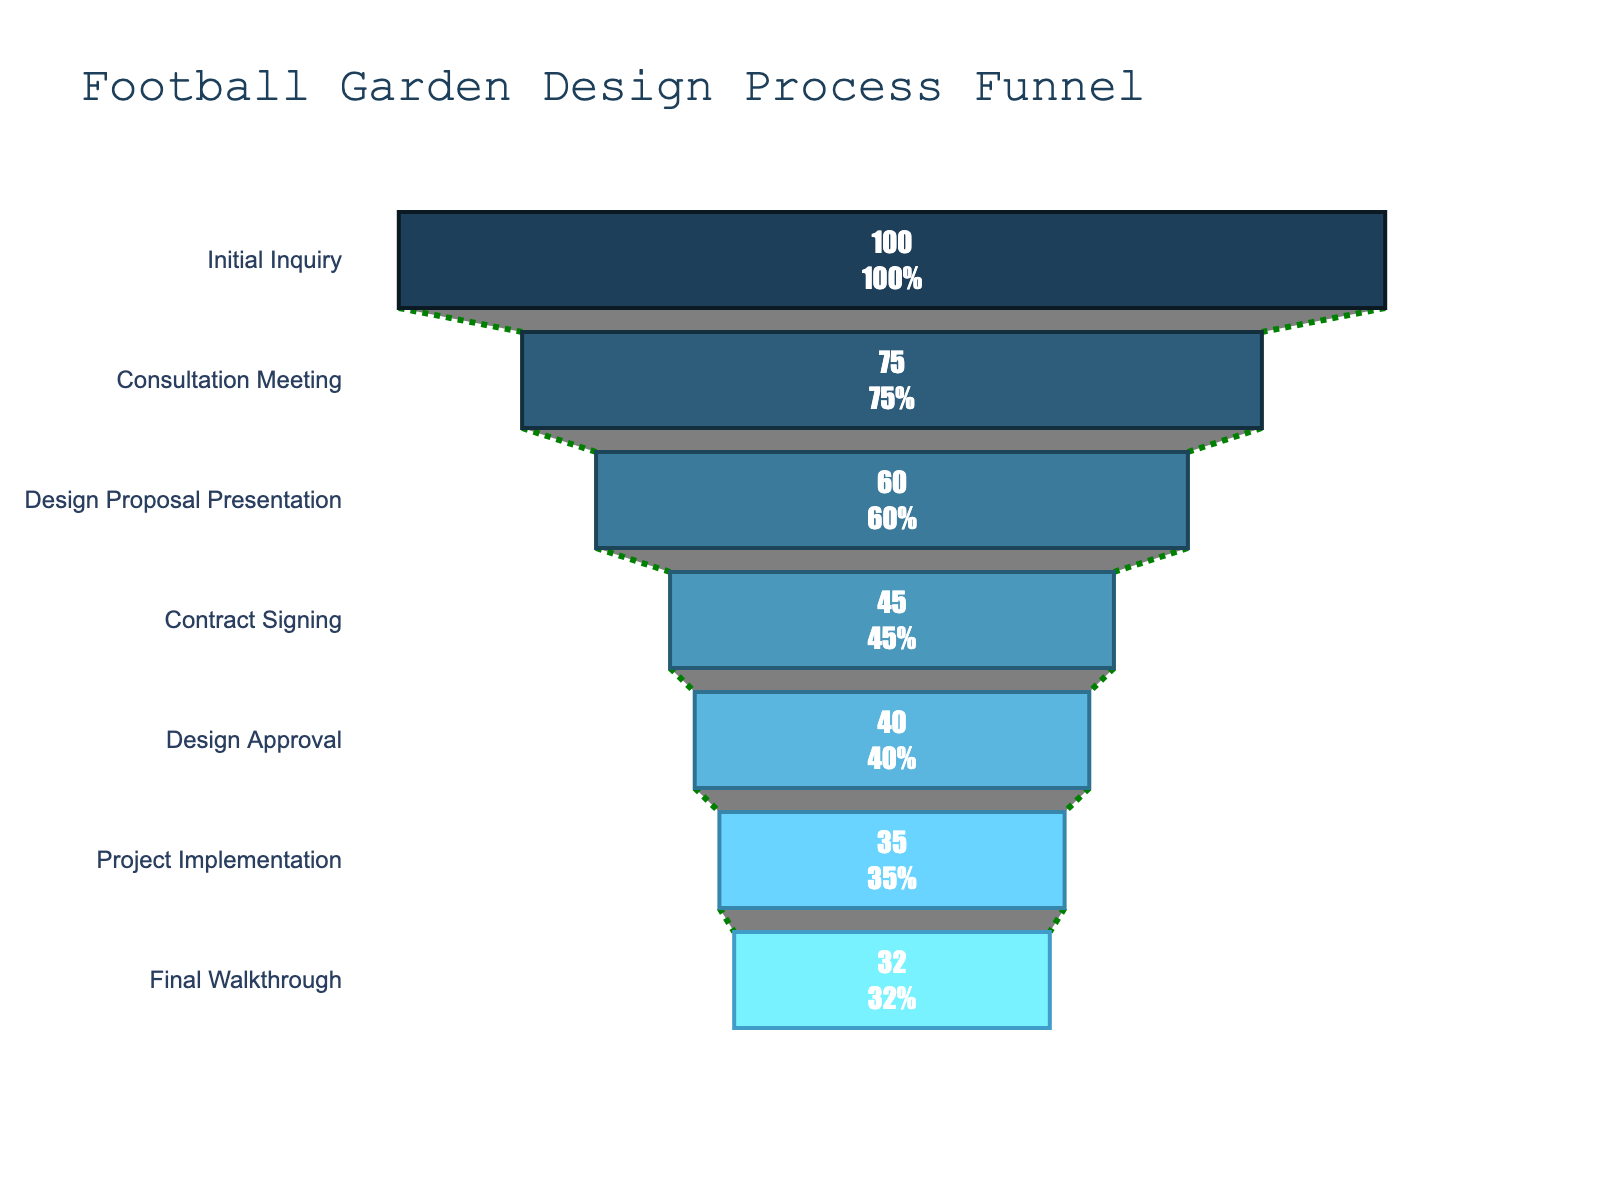What is the title of the funnel chart? The title is usually located at the top of the chart and is labeled as "Football Garden Design Process Funnel". This title indicates the context of the chart, which is relevant to the landscape design process involving football elements.
Answer: Football Garden Design Process Funnel How many stages are shown in the funnel chart? Count the number of distinct stages listed along the Y-axis of the funnel chart. These stages correspond to the different steps in the design process.
Answer: 7 Which stage shows the largest drop in percentage? By examining the percentages between successive stages, the largest drop is identified as the one with the biggest difference. The drop from Initial Inquiry (100) to Consultation Meeting (75) is 25, which is the largest decrement.
Answer: Initial Inquiry to Consultation Meeting What percentage of potential clients sign the contract after the Design Proposal Presentation? Identify the percentage value at the "Contract Signing" stage, which follows the "Design Proposal Presentation" in the funnel chart.
Answer: 45% Out of the stages "Contract Signing" and "Design Approval", which has a lower conversion rate? Compare the percentages of these two stages. The "Contract Signing" stage has 45%, while "Design Approval" has 40%. Therefore, "Design Approval" is lower.
Answer: Design Approval What is the percentage difference between the "Design Proposal Presentation" and the "Final Walkthrough"? Subtract the percentage of the "Final Walkthrough" (32) from "Design Proposal Presentation" (60).
Answer: 28 If 100 people made an Initial Inquiry, how many of them remained at the Final Walkthrough stage? Start with 100 at Initial Inquiry. Then calculate the remaining by applying the given conversion percentages step by step.
Answer: 32 people Which stage comes immediately after "Consultation Meeting"? Locate the stages on the Y-axis. The stage listed directly below "Consultation Meeting" is "Design Proposal Presentation".
Answer: Design Proposal Presentation Is the percentage conversion from "Design Approval" to "Project Implementation" higher or lower than from "Project Implementation" to "Final Walkthrough"? Compare the percentages: "Design Approval" to "Project Implementation" is a drop from 40% to 35% (5 percentage points), whereas "Project Implementation" to "Final Walkthrough" is a drop from 35% to 32% (3 percentage points).
Answer: Higher What is the average conversion rate across all stages? Sum all percentage values and divide by the number of stages: (100 + 75 + 60 + 45 + 40 + 35 + 32)/7.
Answer: 55.3 